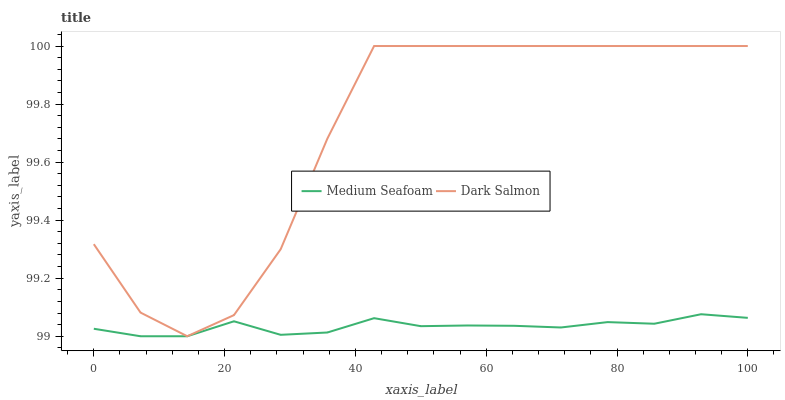Does Medium Seafoam have the minimum area under the curve?
Answer yes or no. Yes. Does Dark Salmon have the maximum area under the curve?
Answer yes or no. Yes. Does Dark Salmon have the minimum area under the curve?
Answer yes or no. No. Is Medium Seafoam the smoothest?
Answer yes or no. Yes. Is Dark Salmon the roughest?
Answer yes or no. Yes. Is Dark Salmon the smoothest?
Answer yes or no. No. Does Medium Seafoam have the lowest value?
Answer yes or no. Yes. Does Dark Salmon have the lowest value?
Answer yes or no. No. Does Dark Salmon have the highest value?
Answer yes or no. Yes. Is Medium Seafoam less than Dark Salmon?
Answer yes or no. Yes. Is Dark Salmon greater than Medium Seafoam?
Answer yes or no. Yes. Does Medium Seafoam intersect Dark Salmon?
Answer yes or no. No. 